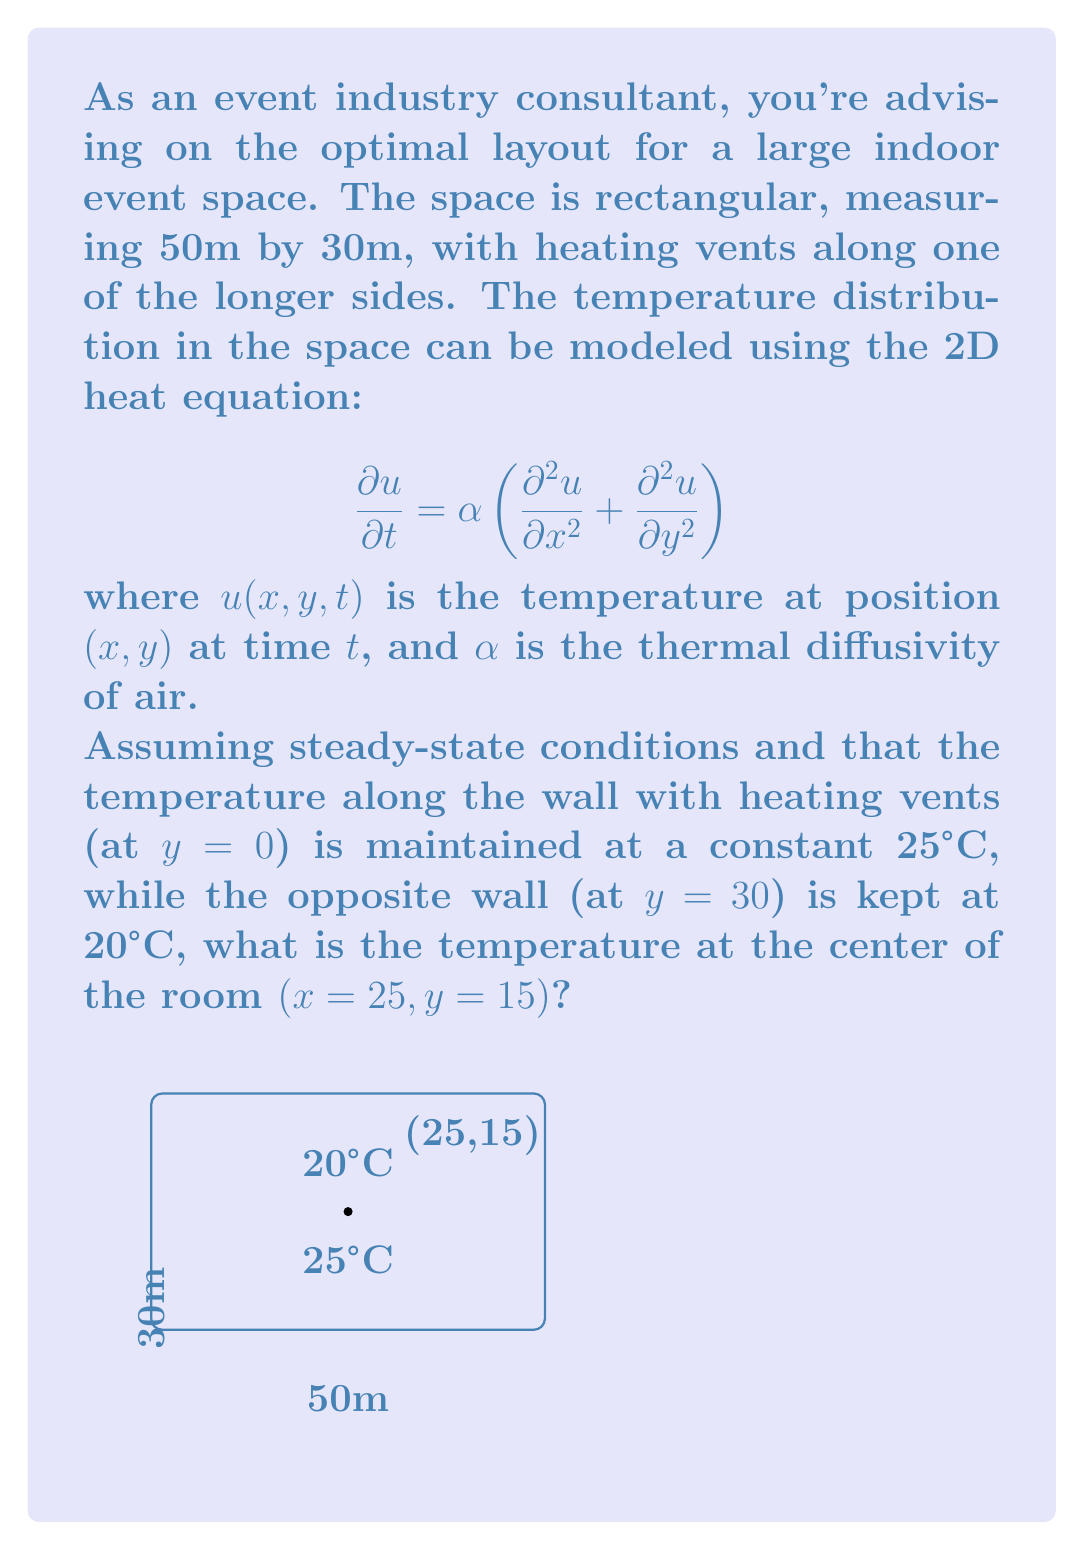Give your solution to this math problem. To solve this problem, we need to use the steady-state heat equation in two dimensions:

1) In steady-state, $\frac{\partial u}{\partial t} = 0$, so our equation reduces to:

   $$\frac{\partial^2 u}{\partial x^2} + \frac{\partial^2 u}{\partial y^2} = 0$$

2) Given the boundary conditions and the fact that temperature only varies in the y-direction (due to the heating vents along one side), we can simplify this to a one-dimensional problem:

   $$\frac{d^2u}{dy^2} = 0$$

3) The general solution to this equation is:

   $$u(y) = Ay + B$$

   where A and B are constants to be determined from the boundary conditions.

4) Applying the boundary conditions:
   At $y = 0$, $u = 25$
   At $y = 30$, $u = 20$

5) Substituting these into our general solution:
   $25 = B$
   $20 = 30A + B$

6) Solving these equations:
   $B = 25$
   $A = -\frac{1}{6}$

7) Therefore, our temperature distribution is:

   $$u(y) = -\frac{1}{6}y + 25$$

8) To find the temperature at the center $(25, 15)$, we substitute $y = 15$:

   $$u(15) = -\frac{1}{6}(15) + 25 = 22.5$$

Thus, the temperature at the center of the room is 22.5°C.
Answer: 22.5°C 